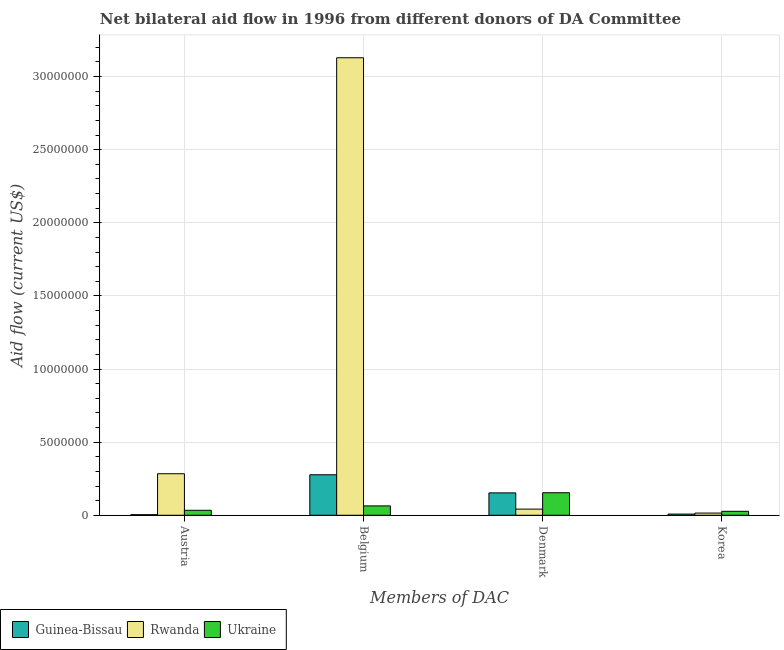How many different coloured bars are there?
Your answer should be very brief. 3. How many groups of bars are there?
Ensure brevity in your answer.  4. How many bars are there on the 4th tick from the left?
Your answer should be very brief. 3. How many bars are there on the 4th tick from the right?
Provide a short and direct response. 3. What is the label of the 3rd group of bars from the left?
Offer a terse response. Denmark. What is the amount of aid given by korea in Guinea-Bissau?
Provide a succinct answer. 8.00e+04. Across all countries, what is the maximum amount of aid given by austria?
Provide a short and direct response. 2.84e+06. Across all countries, what is the minimum amount of aid given by korea?
Provide a succinct answer. 8.00e+04. In which country was the amount of aid given by denmark maximum?
Your answer should be very brief. Ukraine. In which country was the amount of aid given by denmark minimum?
Provide a succinct answer. Rwanda. What is the total amount of aid given by denmark in the graph?
Your answer should be very brief. 3.49e+06. What is the difference between the amount of aid given by austria in Rwanda and that in Guinea-Bissau?
Your answer should be compact. 2.80e+06. What is the difference between the amount of aid given by korea in Rwanda and the amount of aid given by denmark in Guinea-Bissau?
Your response must be concise. -1.38e+06. What is the average amount of aid given by korea per country?
Make the answer very short. 1.67e+05. What is the difference between the amount of aid given by austria and amount of aid given by denmark in Guinea-Bissau?
Offer a terse response. -1.49e+06. In how many countries, is the amount of aid given by denmark greater than 26000000 US$?
Your response must be concise. 0. What is the ratio of the amount of aid given by denmark in Rwanda to that in Ukraine?
Keep it short and to the point. 0.27. Is the difference between the amount of aid given by belgium in Rwanda and Guinea-Bissau greater than the difference between the amount of aid given by korea in Rwanda and Guinea-Bissau?
Offer a terse response. Yes. What is the difference between the highest and the lowest amount of aid given by korea?
Your answer should be very brief. 1.90e+05. Is it the case that in every country, the sum of the amount of aid given by austria and amount of aid given by denmark is greater than the sum of amount of aid given by korea and amount of aid given by belgium?
Offer a very short reply. Yes. What does the 1st bar from the left in Austria represents?
Provide a short and direct response. Guinea-Bissau. What does the 3rd bar from the right in Denmark represents?
Provide a short and direct response. Guinea-Bissau. Is it the case that in every country, the sum of the amount of aid given by austria and amount of aid given by belgium is greater than the amount of aid given by denmark?
Provide a succinct answer. No. How many countries are there in the graph?
Provide a succinct answer. 3. What is the difference between two consecutive major ticks on the Y-axis?
Offer a very short reply. 5.00e+06. How are the legend labels stacked?
Offer a very short reply. Horizontal. What is the title of the graph?
Make the answer very short. Net bilateral aid flow in 1996 from different donors of DA Committee. Does "Argentina" appear as one of the legend labels in the graph?
Keep it short and to the point. No. What is the label or title of the X-axis?
Your answer should be very brief. Members of DAC. What is the label or title of the Y-axis?
Your response must be concise. Aid flow (current US$). What is the Aid flow (current US$) of Rwanda in Austria?
Provide a short and direct response. 2.84e+06. What is the Aid flow (current US$) of Guinea-Bissau in Belgium?
Give a very brief answer. 2.77e+06. What is the Aid flow (current US$) of Rwanda in Belgium?
Provide a succinct answer. 3.13e+07. What is the Aid flow (current US$) of Ukraine in Belgium?
Provide a succinct answer. 6.40e+05. What is the Aid flow (current US$) in Guinea-Bissau in Denmark?
Ensure brevity in your answer.  1.53e+06. What is the Aid flow (current US$) of Rwanda in Denmark?
Give a very brief answer. 4.20e+05. What is the Aid flow (current US$) of Ukraine in Denmark?
Keep it short and to the point. 1.54e+06. What is the Aid flow (current US$) of Ukraine in Korea?
Provide a succinct answer. 2.70e+05. Across all Members of DAC, what is the maximum Aid flow (current US$) in Guinea-Bissau?
Give a very brief answer. 2.77e+06. Across all Members of DAC, what is the maximum Aid flow (current US$) of Rwanda?
Make the answer very short. 3.13e+07. Across all Members of DAC, what is the maximum Aid flow (current US$) of Ukraine?
Ensure brevity in your answer.  1.54e+06. What is the total Aid flow (current US$) of Guinea-Bissau in the graph?
Your answer should be compact. 4.42e+06. What is the total Aid flow (current US$) of Rwanda in the graph?
Provide a short and direct response. 3.47e+07. What is the total Aid flow (current US$) of Ukraine in the graph?
Your answer should be compact. 2.79e+06. What is the difference between the Aid flow (current US$) of Guinea-Bissau in Austria and that in Belgium?
Your response must be concise. -2.73e+06. What is the difference between the Aid flow (current US$) in Rwanda in Austria and that in Belgium?
Give a very brief answer. -2.84e+07. What is the difference between the Aid flow (current US$) of Guinea-Bissau in Austria and that in Denmark?
Ensure brevity in your answer.  -1.49e+06. What is the difference between the Aid flow (current US$) of Rwanda in Austria and that in Denmark?
Offer a terse response. 2.42e+06. What is the difference between the Aid flow (current US$) in Ukraine in Austria and that in Denmark?
Your answer should be very brief. -1.20e+06. What is the difference between the Aid flow (current US$) in Guinea-Bissau in Austria and that in Korea?
Provide a short and direct response. -4.00e+04. What is the difference between the Aid flow (current US$) of Rwanda in Austria and that in Korea?
Provide a short and direct response. 2.69e+06. What is the difference between the Aid flow (current US$) in Ukraine in Austria and that in Korea?
Keep it short and to the point. 7.00e+04. What is the difference between the Aid flow (current US$) of Guinea-Bissau in Belgium and that in Denmark?
Your response must be concise. 1.24e+06. What is the difference between the Aid flow (current US$) in Rwanda in Belgium and that in Denmark?
Offer a very short reply. 3.09e+07. What is the difference between the Aid flow (current US$) in Ukraine in Belgium and that in Denmark?
Keep it short and to the point. -9.00e+05. What is the difference between the Aid flow (current US$) of Guinea-Bissau in Belgium and that in Korea?
Provide a succinct answer. 2.69e+06. What is the difference between the Aid flow (current US$) in Rwanda in Belgium and that in Korea?
Offer a very short reply. 3.11e+07. What is the difference between the Aid flow (current US$) in Ukraine in Belgium and that in Korea?
Give a very brief answer. 3.70e+05. What is the difference between the Aid flow (current US$) in Guinea-Bissau in Denmark and that in Korea?
Ensure brevity in your answer.  1.45e+06. What is the difference between the Aid flow (current US$) of Rwanda in Denmark and that in Korea?
Your answer should be compact. 2.70e+05. What is the difference between the Aid flow (current US$) of Ukraine in Denmark and that in Korea?
Your answer should be compact. 1.27e+06. What is the difference between the Aid flow (current US$) of Guinea-Bissau in Austria and the Aid flow (current US$) of Rwanda in Belgium?
Ensure brevity in your answer.  -3.12e+07. What is the difference between the Aid flow (current US$) in Guinea-Bissau in Austria and the Aid flow (current US$) in Ukraine in Belgium?
Your answer should be very brief. -6.00e+05. What is the difference between the Aid flow (current US$) of Rwanda in Austria and the Aid flow (current US$) of Ukraine in Belgium?
Offer a terse response. 2.20e+06. What is the difference between the Aid flow (current US$) in Guinea-Bissau in Austria and the Aid flow (current US$) in Rwanda in Denmark?
Keep it short and to the point. -3.80e+05. What is the difference between the Aid flow (current US$) in Guinea-Bissau in Austria and the Aid flow (current US$) in Ukraine in Denmark?
Provide a succinct answer. -1.50e+06. What is the difference between the Aid flow (current US$) of Rwanda in Austria and the Aid flow (current US$) of Ukraine in Denmark?
Make the answer very short. 1.30e+06. What is the difference between the Aid flow (current US$) of Guinea-Bissau in Austria and the Aid flow (current US$) of Ukraine in Korea?
Offer a very short reply. -2.30e+05. What is the difference between the Aid flow (current US$) of Rwanda in Austria and the Aid flow (current US$) of Ukraine in Korea?
Keep it short and to the point. 2.57e+06. What is the difference between the Aid flow (current US$) in Guinea-Bissau in Belgium and the Aid flow (current US$) in Rwanda in Denmark?
Keep it short and to the point. 2.35e+06. What is the difference between the Aid flow (current US$) in Guinea-Bissau in Belgium and the Aid flow (current US$) in Ukraine in Denmark?
Offer a terse response. 1.23e+06. What is the difference between the Aid flow (current US$) in Rwanda in Belgium and the Aid flow (current US$) in Ukraine in Denmark?
Provide a short and direct response. 2.98e+07. What is the difference between the Aid flow (current US$) of Guinea-Bissau in Belgium and the Aid flow (current US$) of Rwanda in Korea?
Provide a short and direct response. 2.62e+06. What is the difference between the Aid flow (current US$) of Guinea-Bissau in Belgium and the Aid flow (current US$) of Ukraine in Korea?
Offer a very short reply. 2.50e+06. What is the difference between the Aid flow (current US$) in Rwanda in Belgium and the Aid flow (current US$) in Ukraine in Korea?
Your response must be concise. 3.10e+07. What is the difference between the Aid flow (current US$) in Guinea-Bissau in Denmark and the Aid flow (current US$) in Rwanda in Korea?
Offer a very short reply. 1.38e+06. What is the difference between the Aid flow (current US$) of Guinea-Bissau in Denmark and the Aid flow (current US$) of Ukraine in Korea?
Make the answer very short. 1.26e+06. What is the average Aid flow (current US$) in Guinea-Bissau per Members of DAC?
Ensure brevity in your answer.  1.10e+06. What is the average Aid flow (current US$) in Rwanda per Members of DAC?
Your answer should be very brief. 8.68e+06. What is the average Aid flow (current US$) in Ukraine per Members of DAC?
Offer a very short reply. 6.98e+05. What is the difference between the Aid flow (current US$) in Guinea-Bissau and Aid flow (current US$) in Rwanda in Austria?
Your answer should be very brief. -2.80e+06. What is the difference between the Aid flow (current US$) of Guinea-Bissau and Aid flow (current US$) of Ukraine in Austria?
Provide a succinct answer. -3.00e+05. What is the difference between the Aid flow (current US$) in Rwanda and Aid flow (current US$) in Ukraine in Austria?
Keep it short and to the point. 2.50e+06. What is the difference between the Aid flow (current US$) of Guinea-Bissau and Aid flow (current US$) of Rwanda in Belgium?
Give a very brief answer. -2.85e+07. What is the difference between the Aid flow (current US$) in Guinea-Bissau and Aid flow (current US$) in Ukraine in Belgium?
Your answer should be very brief. 2.13e+06. What is the difference between the Aid flow (current US$) of Rwanda and Aid flow (current US$) of Ukraine in Belgium?
Provide a short and direct response. 3.06e+07. What is the difference between the Aid flow (current US$) of Guinea-Bissau and Aid flow (current US$) of Rwanda in Denmark?
Give a very brief answer. 1.11e+06. What is the difference between the Aid flow (current US$) in Rwanda and Aid flow (current US$) in Ukraine in Denmark?
Ensure brevity in your answer.  -1.12e+06. What is the difference between the Aid flow (current US$) in Guinea-Bissau and Aid flow (current US$) in Rwanda in Korea?
Give a very brief answer. -7.00e+04. What is the difference between the Aid flow (current US$) of Guinea-Bissau and Aid flow (current US$) of Ukraine in Korea?
Keep it short and to the point. -1.90e+05. What is the difference between the Aid flow (current US$) in Rwanda and Aid flow (current US$) in Ukraine in Korea?
Keep it short and to the point. -1.20e+05. What is the ratio of the Aid flow (current US$) in Guinea-Bissau in Austria to that in Belgium?
Make the answer very short. 0.01. What is the ratio of the Aid flow (current US$) in Rwanda in Austria to that in Belgium?
Ensure brevity in your answer.  0.09. What is the ratio of the Aid flow (current US$) in Ukraine in Austria to that in Belgium?
Provide a succinct answer. 0.53. What is the ratio of the Aid flow (current US$) of Guinea-Bissau in Austria to that in Denmark?
Offer a very short reply. 0.03. What is the ratio of the Aid flow (current US$) in Rwanda in Austria to that in Denmark?
Your answer should be compact. 6.76. What is the ratio of the Aid flow (current US$) in Ukraine in Austria to that in Denmark?
Give a very brief answer. 0.22. What is the ratio of the Aid flow (current US$) of Rwanda in Austria to that in Korea?
Provide a succinct answer. 18.93. What is the ratio of the Aid flow (current US$) of Ukraine in Austria to that in Korea?
Ensure brevity in your answer.  1.26. What is the ratio of the Aid flow (current US$) in Guinea-Bissau in Belgium to that in Denmark?
Make the answer very short. 1.81. What is the ratio of the Aid flow (current US$) of Rwanda in Belgium to that in Denmark?
Your response must be concise. 74.5. What is the ratio of the Aid flow (current US$) of Ukraine in Belgium to that in Denmark?
Your answer should be very brief. 0.42. What is the ratio of the Aid flow (current US$) in Guinea-Bissau in Belgium to that in Korea?
Provide a short and direct response. 34.62. What is the ratio of the Aid flow (current US$) in Rwanda in Belgium to that in Korea?
Give a very brief answer. 208.6. What is the ratio of the Aid flow (current US$) of Ukraine in Belgium to that in Korea?
Your answer should be very brief. 2.37. What is the ratio of the Aid flow (current US$) of Guinea-Bissau in Denmark to that in Korea?
Your response must be concise. 19.12. What is the ratio of the Aid flow (current US$) in Rwanda in Denmark to that in Korea?
Keep it short and to the point. 2.8. What is the ratio of the Aid flow (current US$) in Ukraine in Denmark to that in Korea?
Give a very brief answer. 5.7. What is the difference between the highest and the second highest Aid flow (current US$) of Guinea-Bissau?
Offer a terse response. 1.24e+06. What is the difference between the highest and the second highest Aid flow (current US$) of Rwanda?
Provide a succinct answer. 2.84e+07. What is the difference between the highest and the second highest Aid flow (current US$) in Ukraine?
Your answer should be very brief. 9.00e+05. What is the difference between the highest and the lowest Aid flow (current US$) in Guinea-Bissau?
Offer a terse response. 2.73e+06. What is the difference between the highest and the lowest Aid flow (current US$) in Rwanda?
Keep it short and to the point. 3.11e+07. What is the difference between the highest and the lowest Aid flow (current US$) in Ukraine?
Your answer should be compact. 1.27e+06. 